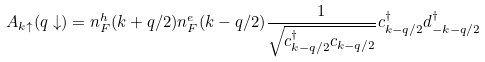Convert formula to latex. <formula><loc_0><loc_0><loc_500><loc_500>A _ { { k } \uparrow } ( { q } \downarrow ) = n ^ { h } _ { F } ( { k } + { q } / 2 ) n ^ { e } _ { F } ( { k } - { q } / 2 ) \frac { 1 } { \sqrt { c ^ { \dagger } _ { { k } - { q } / 2 } c _ { { k } - { q } / 2 } } } c ^ { \dagger } _ { { k } - { q } / 2 } d ^ { \dagger } _ { - { k } - { q } / 2 }</formula> 